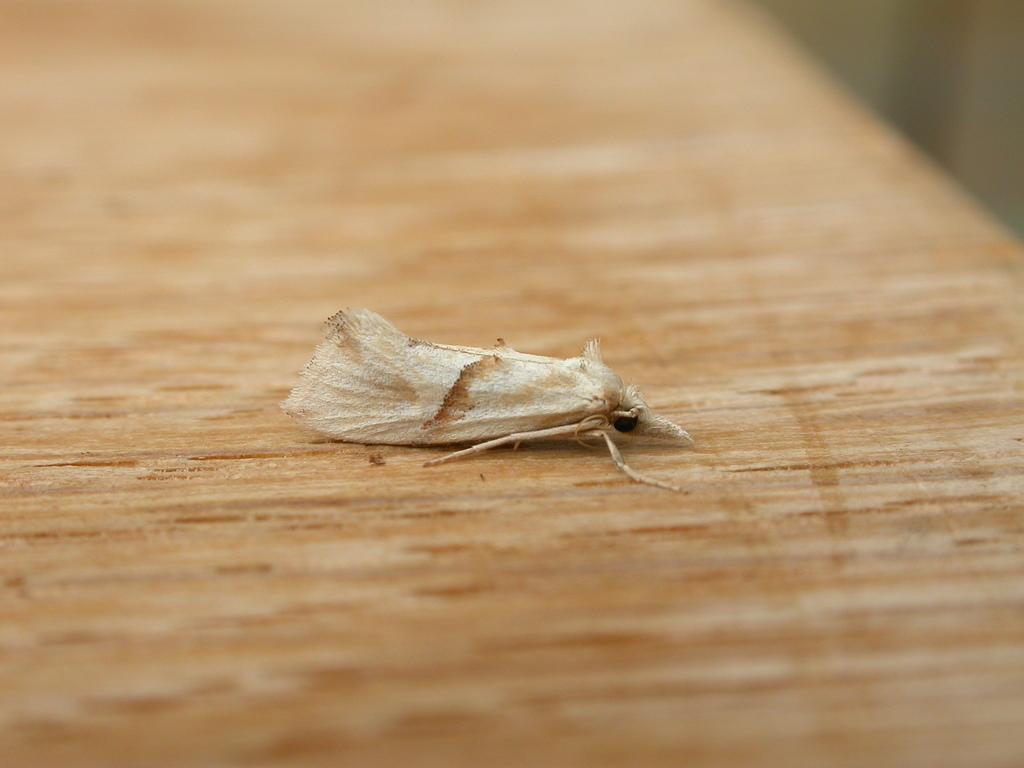How would you summarize this image in a sentence or two? In the center of the image we can see a fly on the wood. 